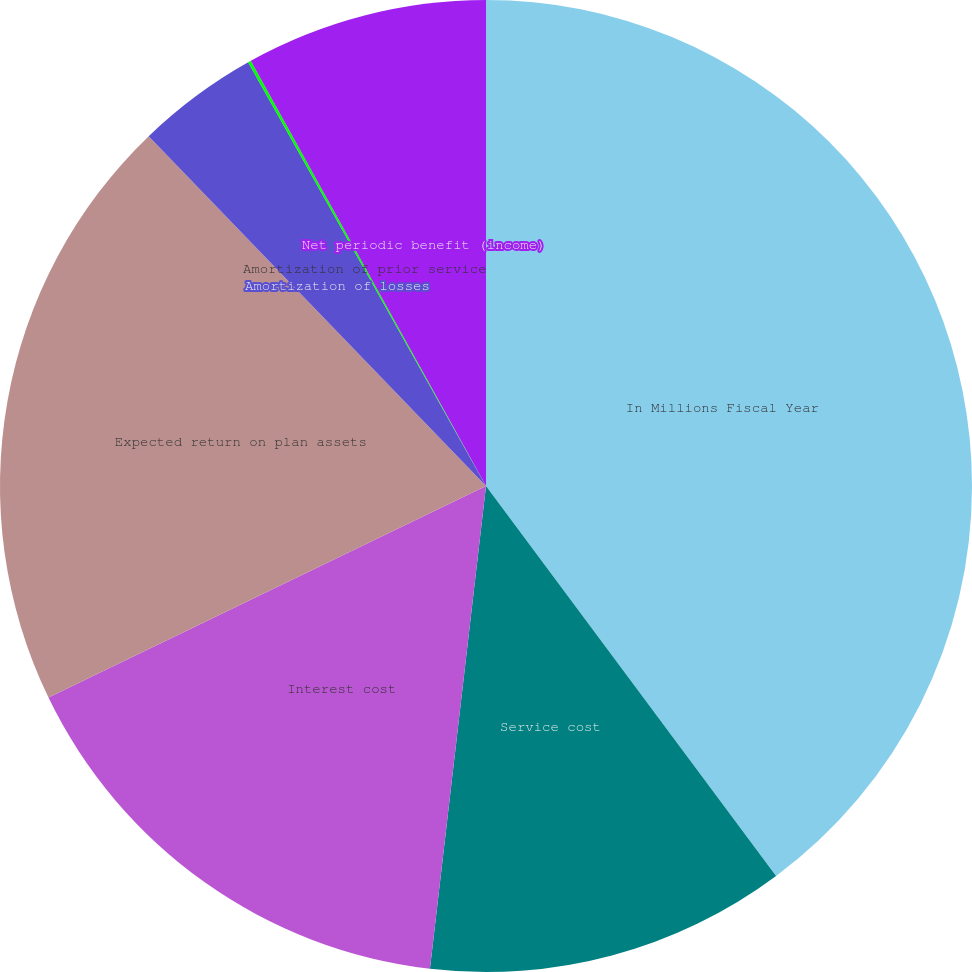<chart> <loc_0><loc_0><loc_500><loc_500><pie_chart><fcel>In Millions Fiscal Year<fcel>Service cost<fcel>Interest cost<fcel>Expected return on plan assets<fcel>Amortization of losses<fcel>Amortization of prior service<fcel>Net periodic benefit (income)<nl><fcel>39.82%<fcel>12.02%<fcel>15.99%<fcel>19.96%<fcel>4.07%<fcel>0.1%<fcel>8.04%<nl></chart> 